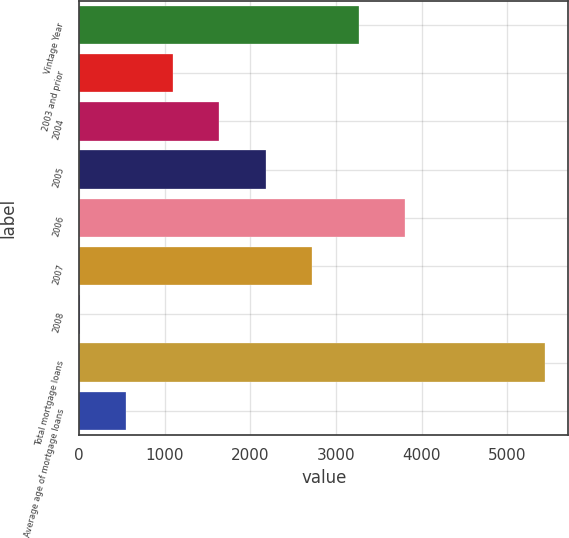<chart> <loc_0><loc_0><loc_500><loc_500><bar_chart><fcel>Vintage Year<fcel>2003 and prior<fcel>2004<fcel>2005<fcel>2006<fcel>2007<fcel>2008<fcel>Total mortgage loans<fcel>Average age of mortgage loans<nl><fcel>3266.92<fcel>1091.64<fcel>1635.46<fcel>2179.28<fcel>3810.74<fcel>2723.1<fcel>4<fcel>5442.2<fcel>547.82<nl></chart> 